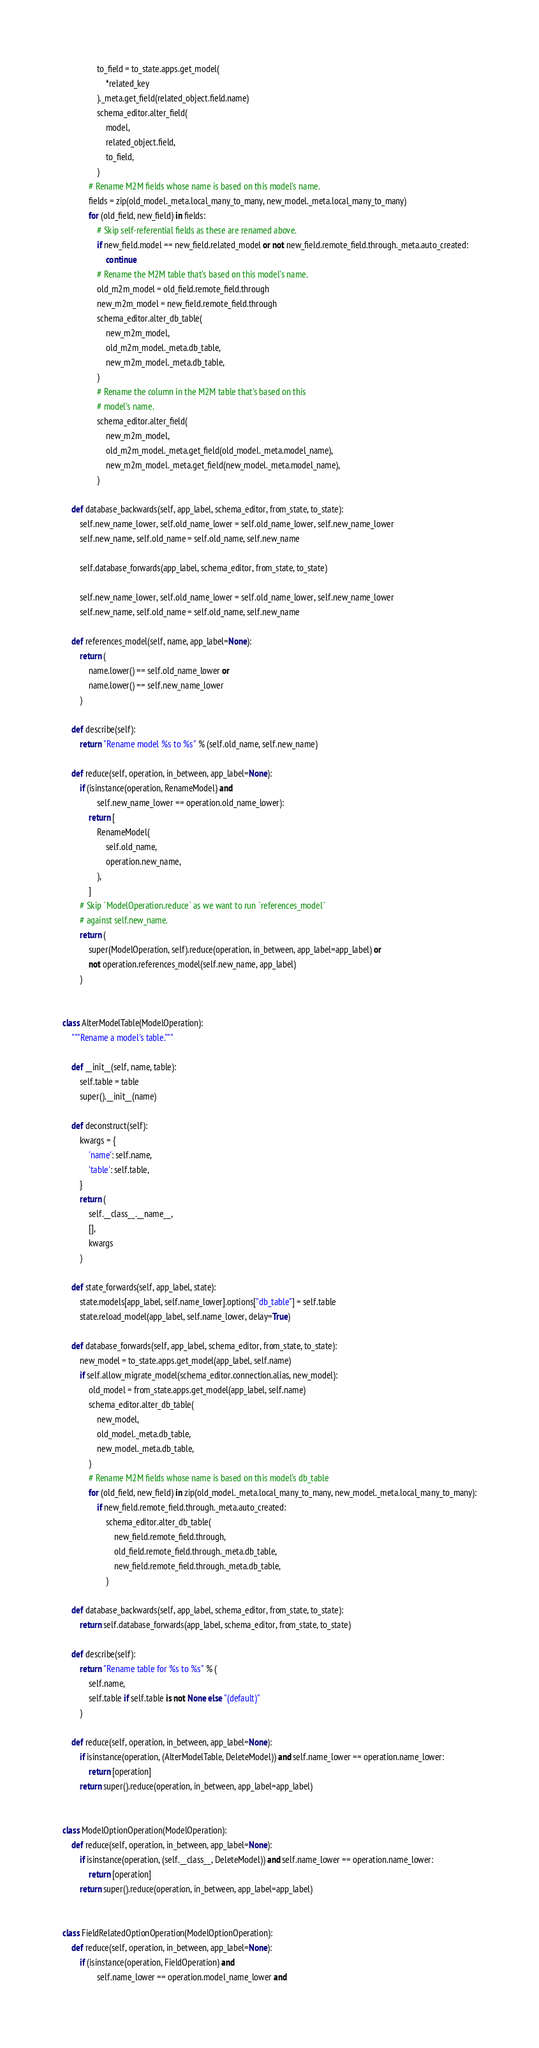Convert code to text. <code><loc_0><loc_0><loc_500><loc_500><_Python_>                to_field = to_state.apps.get_model(
                    *related_key
                )._meta.get_field(related_object.field.name)
                schema_editor.alter_field(
                    model,
                    related_object.field,
                    to_field,
                )
            # Rename M2M fields whose name is based on this model's name.
            fields = zip(old_model._meta.local_many_to_many, new_model._meta.local_many_to_many)
            for (old_field, new_field) in fields:
                # Skip self-referential fields as these are renamed above.
                if new_field.model == new_field.related_model or not new_field.remote_field.through._meta.auto_created:
                    continue
                # Rename the M2M table that's based on this model's name.
                old_m2m_model = old_field.remote_field.through
                new_m2m_model = new_field.remote_field.through
                schema_editor.alter_db_table(
                    new_m2m_model,
                    old_m2m_model._meta.db_table,
                    new_m2m_model._meta.db_table,
                )
                # Rename the column in the M2M table that's based on this
                # model's name.
                schema_editor.alter_field(
                    new_m2m_model,
                    old_m2m_model._meta.get_field(old_model._meta.model_name),
                    new_m2m_model._meta.get_field(new_model._meta.model_name),
                )

    def database_backwards(self, app_label, schema_editor, from_state, to_state):
        self.new_name_lower, self.old_name_lower = self.old_name_lower, self.new_name_lower
        self.new_name, self.old_name = self.old_name, self.new_name

        self.database_forwards(app_label, schema_editor, from_state, to_state)

        self.new_name_lower, self.old_name_lower = self.old_name_lower, self.new_name_lower
        self.new_name, self.old_name = self.old_name, self.new_name

    def references_model(self, name, app_label=None):
        return (
            name.lower() == self.old_name_lower or
            name.lower() == self.new_name_lower
        )

    def describe(self):
        return "Rename model %s to %s" % (self.old_name, self.new_name)

    def reduce(self, operation, in_between, app_label=None):
        if (isinstance(operation, RenameModel) and
                self.new_name_lower == operation.old_name_lower):
            return [
                RenameModel(
                    self.old_name,
                    operation.new_name,
                ),
            ]
        # Skip `ModelOperation.reduce` as we want to run `references_model`
        # against self.new_name.
        return (
            super(ModelOperation, self).reduce(operation, in_between, app_label=app_label) or
            not operation.references_model(self.new_name, app_label)
        )


class AlterModelTable(ModelOperation):
    """Rename a model's table."""

    def __init__(self, name, table):
        self.table = table
        super().__init__(name)

    def deconstruct(self):
        kwargs = {
            'name': self.name,
            'table': self.table,
        }
        return (
            self.__class__.__name__,
            [],
            kwargs
        )

    def state_forwards(self, app_label, state):
        state.models[app_label, self.name_lower].options["db_table"] = self.table
        state.reload_model(app_label, self.name_lower, delay=True)

    def database_forwards(self, app_label, schema_editor, from_state, to_state):
        new_model = to_state.apps.get_model(app_label, self.name)
        if self.allow_migrate_model(schema_editor.connection.alias, new_model):
            old_model = from_state.apps.get_model(app_label, self.name)
            schema_editor.alter_db_table(
                new_model,
                old_model._meta.db_table,
                new_model._meta.db_table,
            )
            # Rename M2M fields whose name is based on this model's db_table
            for (old_field, new_field) in zip(old_model._meta.local_many_to_many, new_model._meta.local_many_to_many):
                if new_field.remote_field.through._meta.auto_created:
                    schema_editor.alter_db_table(
                        new_field.remote_field.through,
                        old_field.remote_field.through._meta.db_table,
                        new_field.remote_field.through._meta.db_table,
                    )

    def database_backwards(self, app_label, schema_editor, from_state, to_state):
        return self.database_forwards(app_label, schema_editor, from_state, to_state)

    def describe(self):
        return "Rename table for %s to %s" % (
            self.name,
            self.table if self.table is not None else "(default)"
        )

    def reduce(self, operation, in_between, app_label=None):
        if isinstance(operation, (AlterModelTable, DeleteModel)) and self.name_lower == operation.name_lower:
            return [operation]
        return super().reduce(operation, in_between, app_label=app_label)


class ModelOptionOperation(ModelOperation):
    def reduce(self, operation, in_between, app_label=None):
        if isinstance(operation, (self.__class__, DeleteModel)) and self.name_lower == operation.name_lower:
            return [operation]
        return super().reduce(operation, in_between, app_label=app_label)


class FieldRelatedOptionOperation(ModelOptionOperation):
    def reduce(self, operation, in_between, app_label=None):
        if (isinstance(operation, FieldOperation) and
                self.name_lower == operation.model_name_lower and</code> 